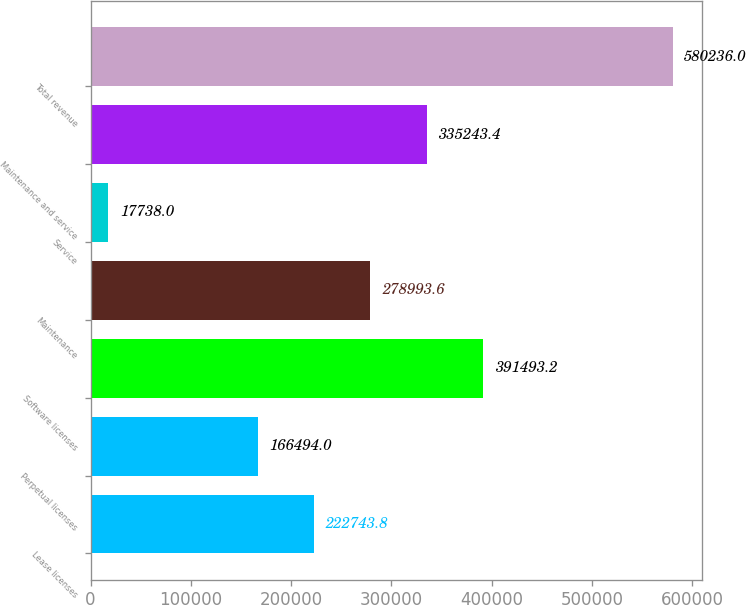Convert chart. <chart><loc_0><loc_0><loc_500><loc_500><bar_chart><fcel>Lease licenses<fcel>Perpetual licenses<fcel>Software licenses<fcel>Maintenance<fcel>Service<fcel>Maintenance and service<fcel>Total revenue<nl><fcel>222744<fcel>166494<fcel>391493<fcel>278994<fcel>17738<fcel>335243<fcel>580236<nl></chart> 